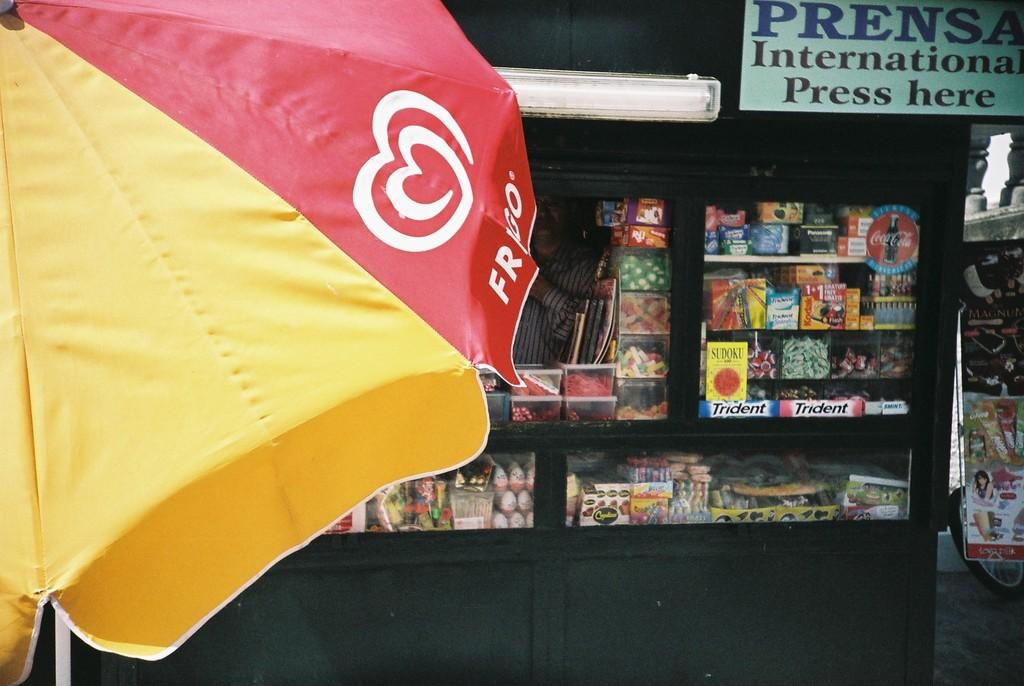What object is present in the image that can provide shelter from the rain? There is an umbrella in the image. What type of structure can be seen in the image? There is a stall in the image. Can you describe the person in the image? There is a person standing in the image. What is the purpose of the board with text in the image? The board with text in the image may be used for displaying information or advertisements. What time is displayed on the clock in the image? There is no clock present in the image, so the time cannot be determined. What type of art can be seen on the walls of the stall in the image? There is no art visible on the walls of the stall in the image. 